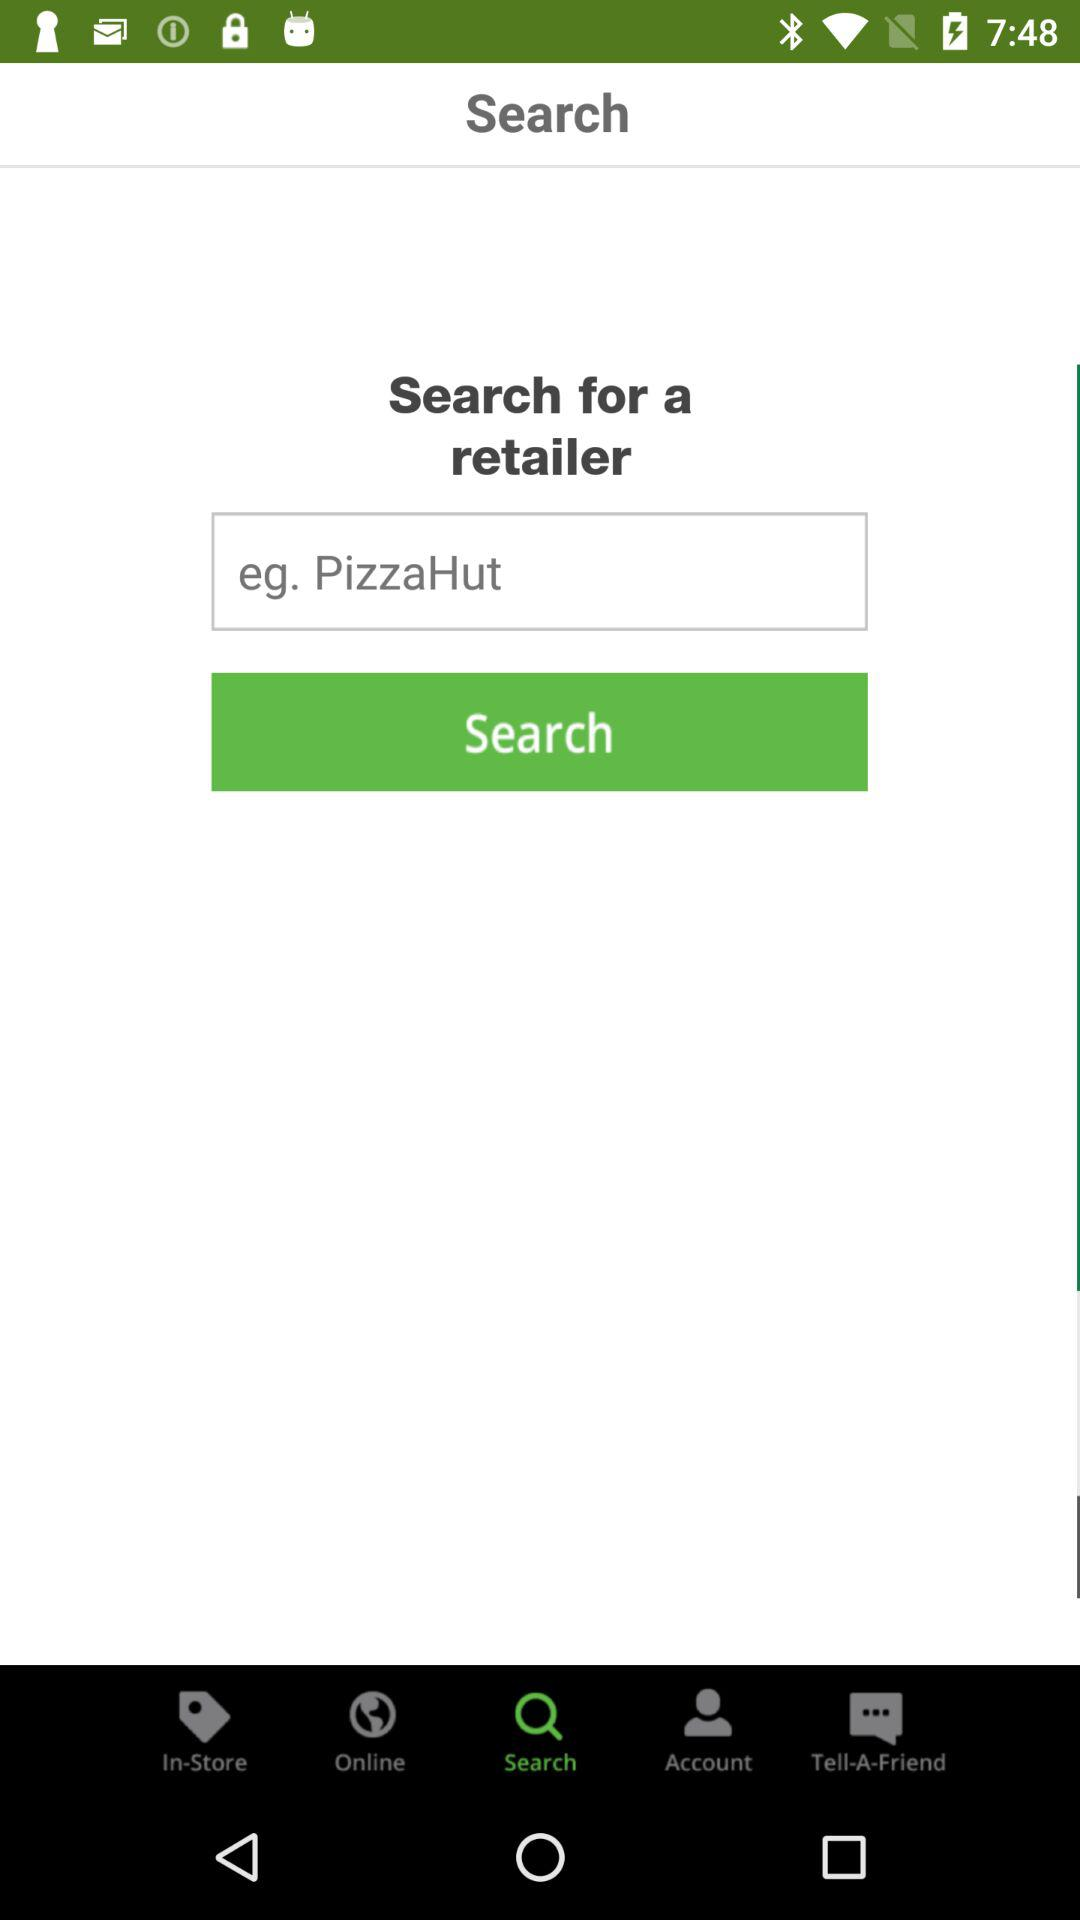Which option is selected? The selected option is "Search". 